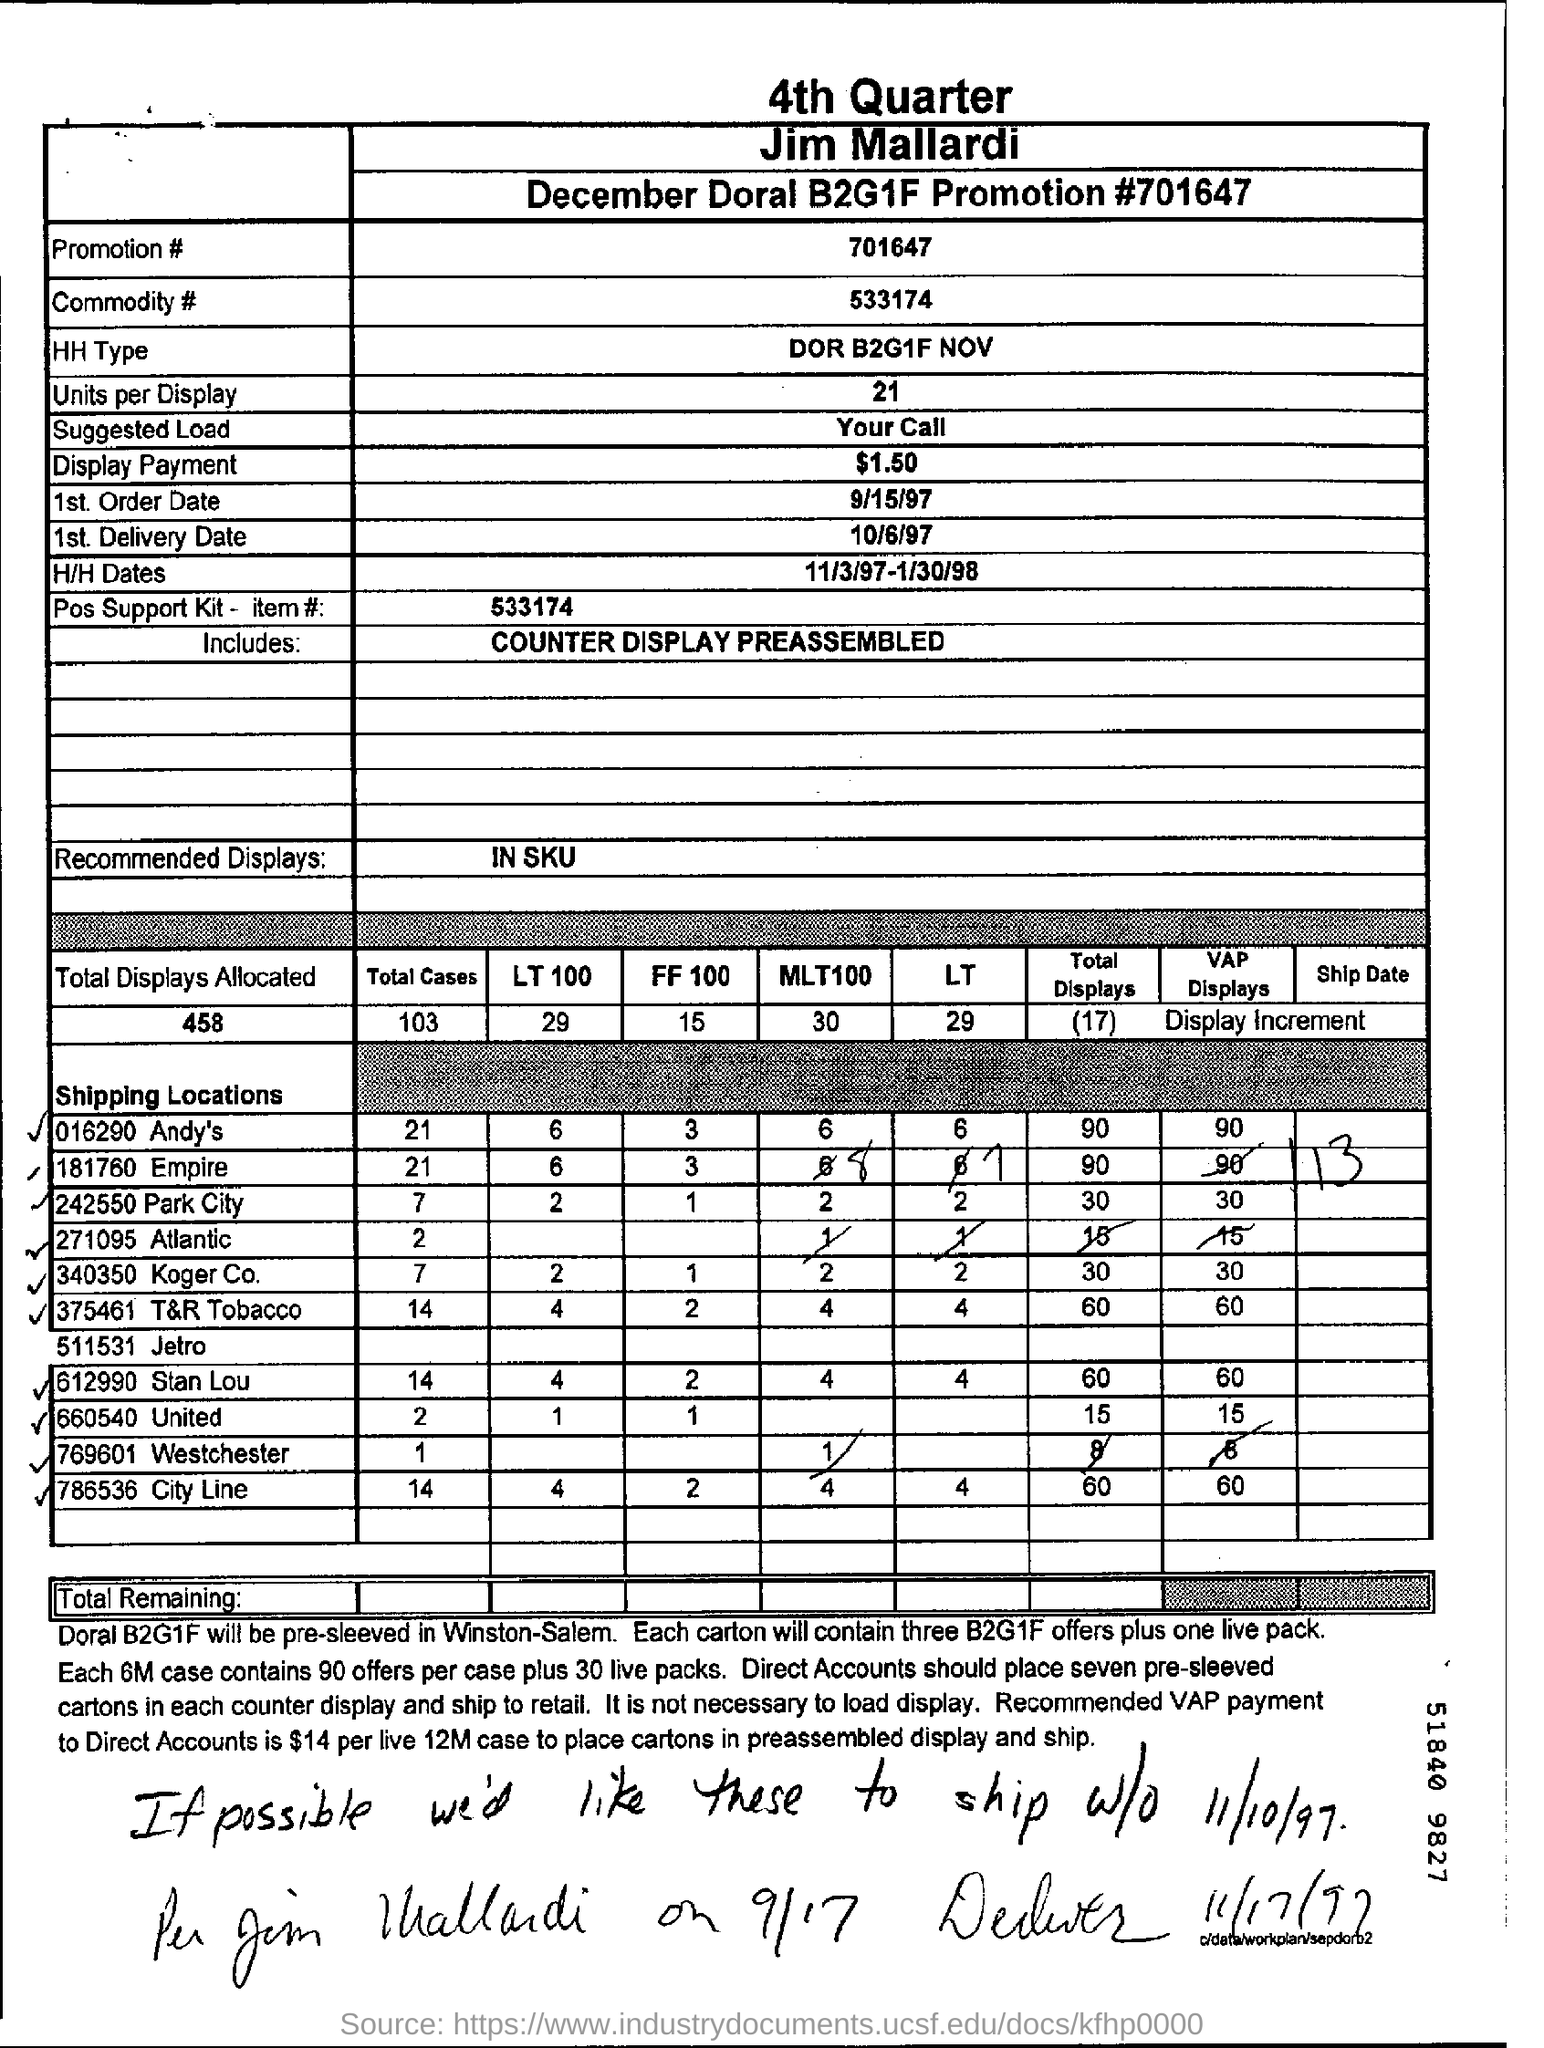List a handful of essential elements in this visual. The first order date is September 15, 1997. What is the promotion number? It is 701647... What is the commodity number? It is 533174... The Pos Support Kit, item #533174, is a tool designed to provide support for point of sale systems. The number of units per display is 21. 